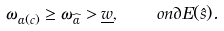Convert formula to latex. <formula><loc_0><loc_0><loc_500><loc_500>\omega _ { \alpha ( c ) } \geq \omega _ { \widehat { \alpha } } > \underline { w } , \quad o n \partial { E ( \hat { s } ) } .</formula> 